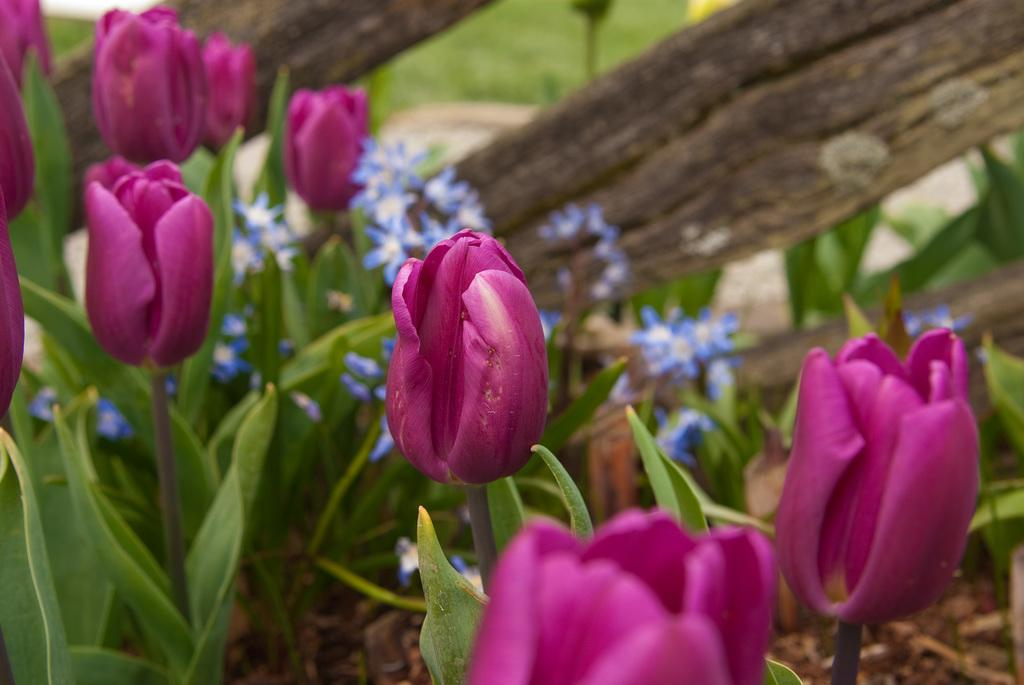What type of plants can be seen in the image? There are flowers and leaves in the image. What material is the fence made of in the image? The fence in the image is made of wood. How does the temper of the flowers affect the growth of the leaves in the image? There is no indication of the temper of the flowers or its effect on the growth of the leaves in the image, as these concepts are not related to the visual elements present. 